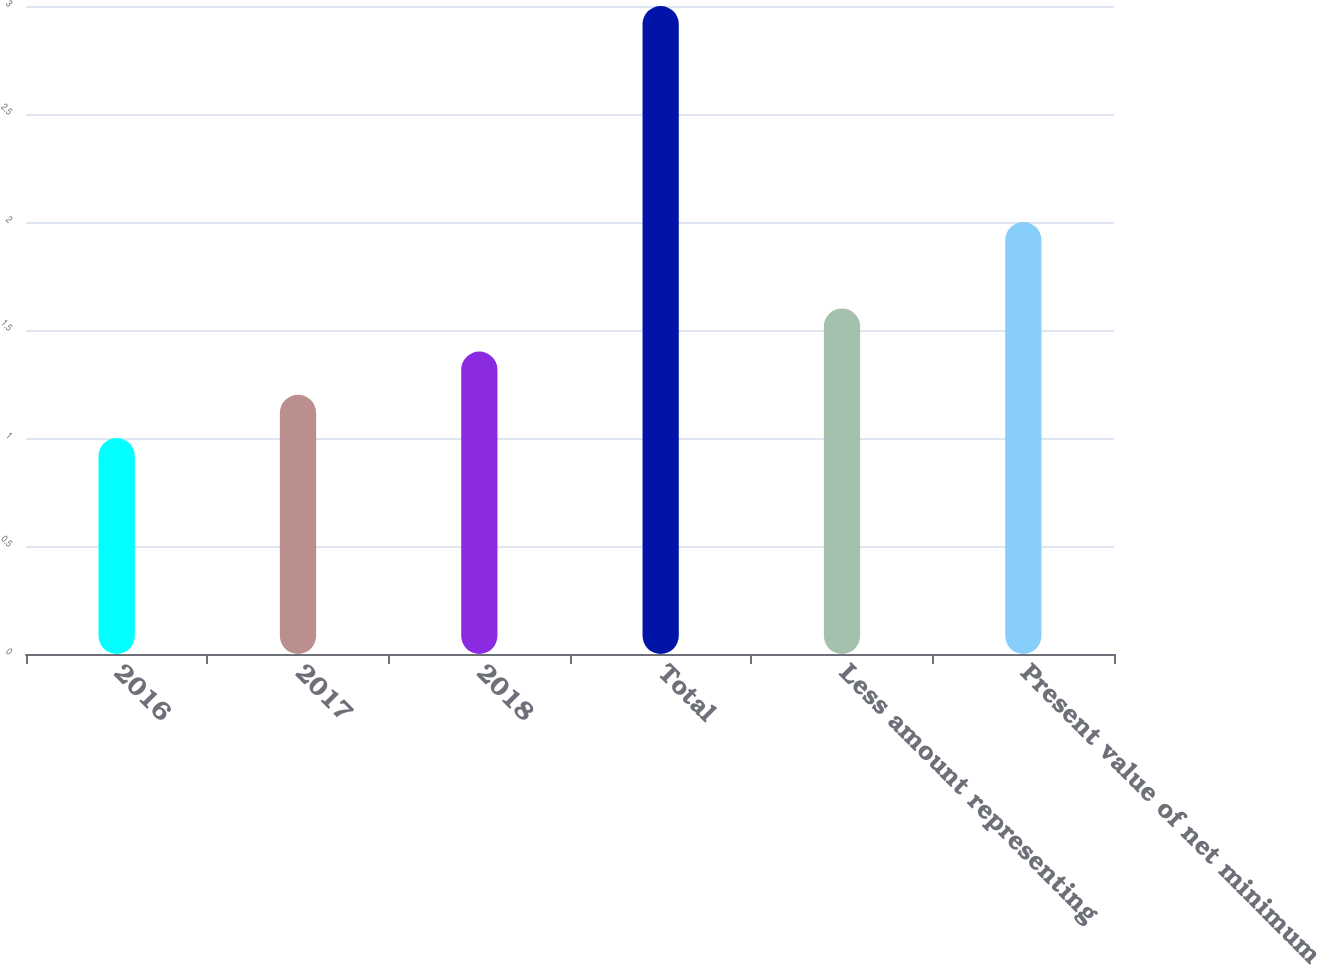Convert chart to OTSL. <chart><loc_0><loc_0><loc_500><loc_500><bar_chart><fcel>2016<fcel>2017<fcel>2018<fcel>Total<fcel>Less amount representing<fcel>Present value of net minimum<nl><fcel>1<fcel>1.2<fcel>1.4<fcel>3<fcel>1.6<fcel>2<nl></chart> 